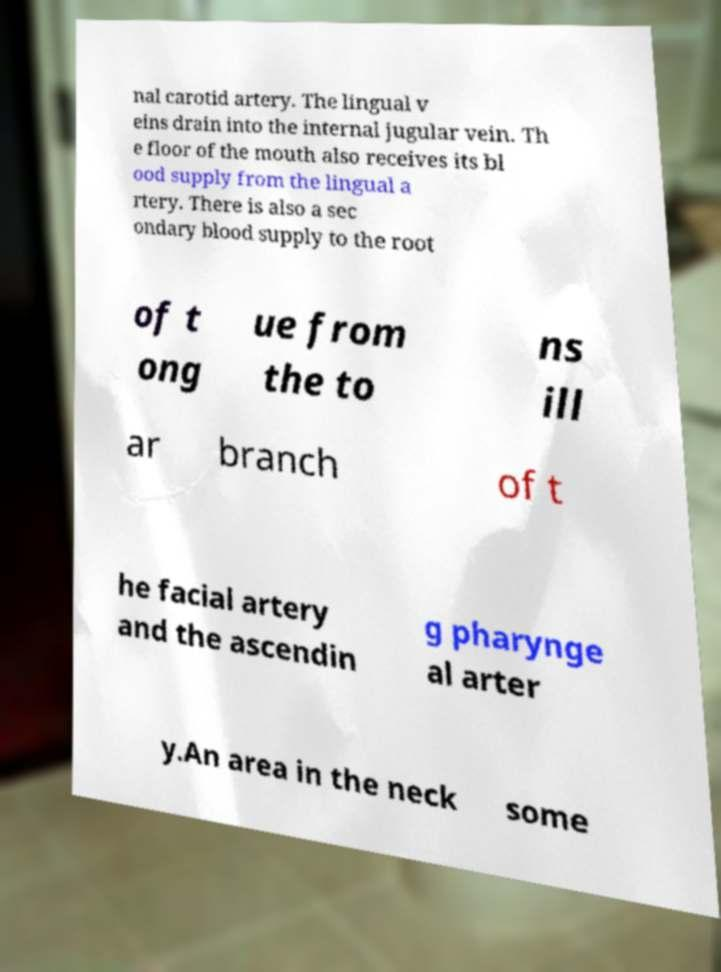Please read and relay the text visible in this image. What does it say? nal carotid artery. The lingual v eins drain into the internal jugular vein. Th e floor of the mouth also receives its bl ood supply from the lingual a rtery. There is also a sec ondary blood supply to the root of t ong ue from the to ns ill ar branch of t he facial artery and the ascendin g pharynge al arter y.An area in the neck some 